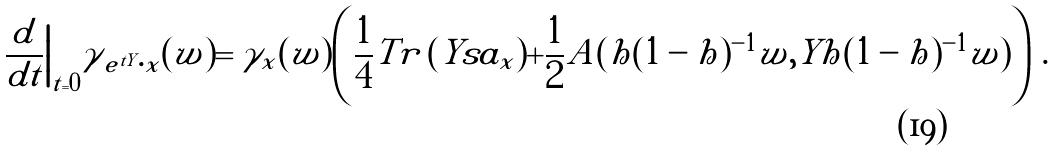<formula> <loc_0><loc_0><loc_500><loc_500>\frac { d } { d t } \Big | _ { t = 0 } \gamma _ { \, e ^ { t Y } \cdot x } ( w ) = \gamma _ { x } ( w ) \left ( { \frac { 1 } { 4 } } T r \, ( Y s a _ { x } ) + { \frac { 1 } { 2 } } A ( h ( 1 - h ) ^ { - 1 } w , Y h ( 1 - h ) ^ { - 1 } w ) \right ) \, .</formula> 